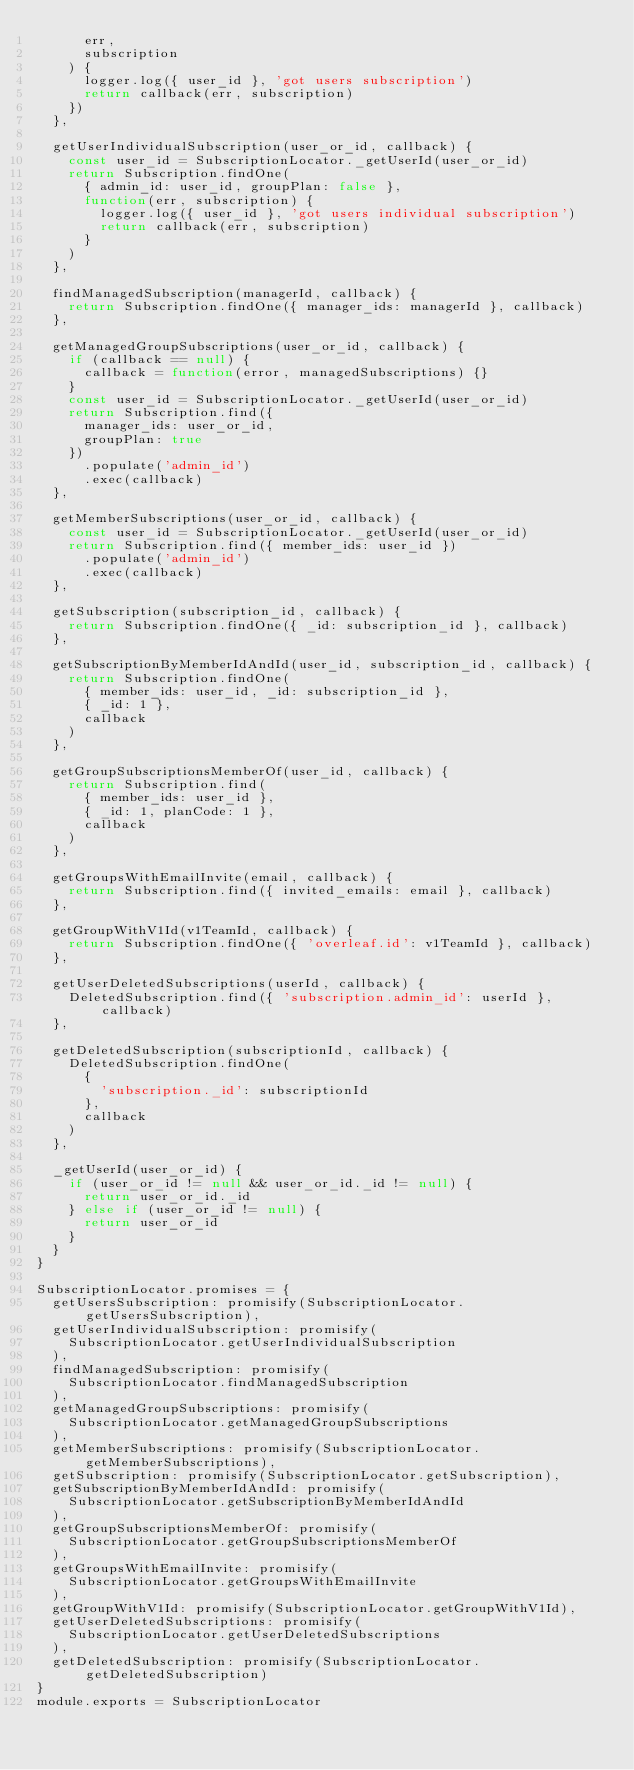<code> <loc_0><loc_0><loc_500><loc_500><_JavaScript_>      err,
      subscription
    ) {
      logger.log({ user_id }, 'got users subscription')
      return callback(err, subscription)
    })
  },

  getUserIndividualSubscription(user_or_id, callback) {
    const user_id = SubscriptionLocator._getUserId(user_or_id)
    return Subscription.findOne(
      { admin_id: user_id, groupPlan: false },
      function(err, subscription) {
        logger.log({ user_id }, 'got users individual subscription')
        return callback(err, subscription)
      }
    )
  },

  findManagedSubscription(managerId, callback) {
    return Subscription.findOne({ manager_ids: managerId }, callback)
  },

  getManagedGroupSubscriptions(user_or_id, callback) {
    if (callback == null) {
      callback = function(error, managedSubscriptions) {}
    }
    const user_id = SubscriptionLocator._getUserId(user_or_id)
    return Subscription.find({
      manager_ids: user_or_id,
      groupPlan: true
    })
      .populate('admin_id')
      .exec(callback)
  },

  getMemberSubscriptions(user_or_id, callback) {
    const user_id = SubscriptionLocator._getUserId(user_or_id)
    return Subscription.find({ member_ids: user_id })
      .populate('admin_id')
      .exec(callback)
  },

  getSubscription(subscription_id, callback) {
    return Subscription.findOne({ _id: subscription_id }, callback)
  },

  getSubscriptionByMemberIdAndId(user_id, subscription_id, callback) {
    return Subscription.findOne(
      { member_ids: user_id, _id: subscription_id },
      { _id: 1 },
      callback
    )
  },

  getGroupSubscriptionsMemberOf(user_id, callback) {
    return Subscription.find(
      { member_ids: user_id },
      { _id: 1, planCode: 1 },
      callback
    )
  },

  getGroupsWithEmailInvite(email, callback) {
    return Subscription.find({ invited_emails: email }, callback)
  },

  getGroupWithV1Id(v1TeamId, callback) {
    return Subscription.findOne({ 'overleaf.id': v1TeamId }, callback)
  },

  getUserDeletedSubscriptions(userId, callback) {
    DeletedSubscription.find({ 'subscription.admin_id': userId }, callback)
  },

  getDeletedSubscription(subscriptionId, callback) {
    DeletedSubscription.findOne(
      {
        'subscription._id': subscriptionId
      },
      callback
    )
  },

  _getUserId(user_or_id) {
    if (user_or_id != null && user_or_id._id != null) {
      return user_or_id._id
    } else if (user_or_id != null) {
      return user_or_id
    }
  }
}

SubscriptionLocator.promises = {
  getUsersSubscription: promisify(SubscriptionLocator.getUsersSubscription),
  getUserIndividualSubscription: promisify(
    SubscriptionLocator.getUserIndividualSubscription
  ),
  findManagedSubscription: promisify(
    SubscriptionLocator.findManagedSubscription
  ),
  getManagedGroupSubscriptions: promisify(
    SubscriptionLocator.getManagedGroupSubscriptions
  ),
  getMemberSubscriptions: promisify(SubscriptionLocator.getMemberSubscriptions),
  getSubscription: promisify(SubscriptionLocator.getSubscription),
  getSubscriptionByMemberIdAndId: promisify(
    SubscriptionLocator.getSubscriptionByMemberIdAndId
  ),
  getGroupSubscriptionsMemberOf: promisify(
    SubscriptionLocator.getGroupSubscriptionsMemberOf
  ),
  getGroupsWithEmailInvite: promisify(
    SubscriptionLocator.getGroupsWithEmailInvite
  ),
  getGroupWithV1Id: promisify(SubscriptionLocator.getGroupWithV1Id),
  getUserDeletedSubscriptions: promisify(
    SubscriptionLocator.getUserDeletedSubscriptions
  ),
  getDeletedSubscription: promisify(SubscriptionLocator.getDeletedSubscription)
}
module.exports = SubscriptionLocator
</code> 